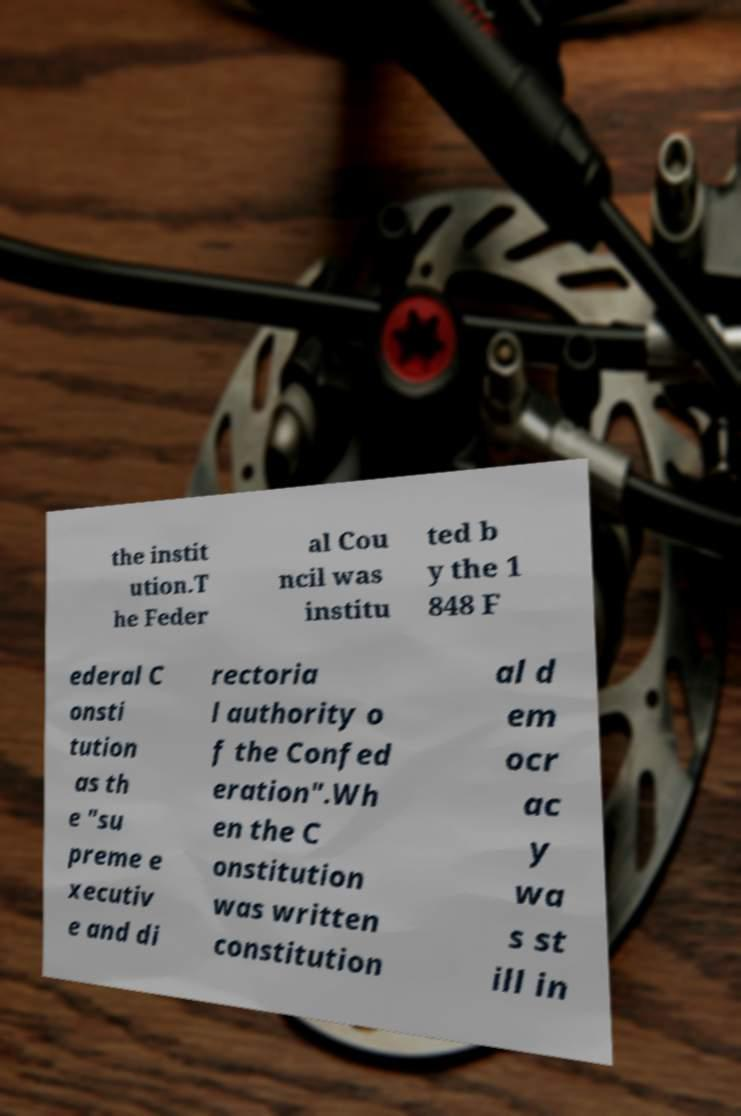Please identify and transcribe the text found in this image. the instit ution.T he Feder al Cou ncil was institu ted b y the 1 848 F ederal C onsti tution as th e "su preme e xecutiv e and di rectoria l authority o f the Confed eration".Wh en the C onstitution was written constitution al d em ocr ac y wa s st ill in 